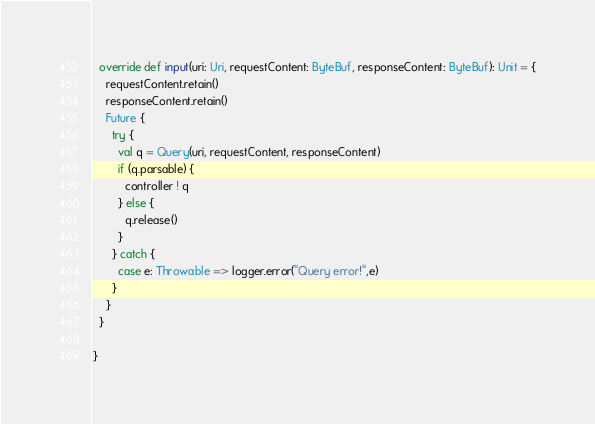Convert code to text. <code><loc_0><loc_0><loc_500><loc_500><_Scala_>  override def input(uri: Uri, requestContent: ByteBuf, responseContent: ByteBuf): Unit = {
    requestContent.retain()
    responseContent.retain()
    Future {
      try {
        val q = Query(uri, requestContent, responseContent)
        if (q.parsable) {
          controller ! q
        } else {
          q.release()
        }
      } catch {
        case e: Throwable => logger.error("Query error!",e)
      }
    }
  }

}
</code> 